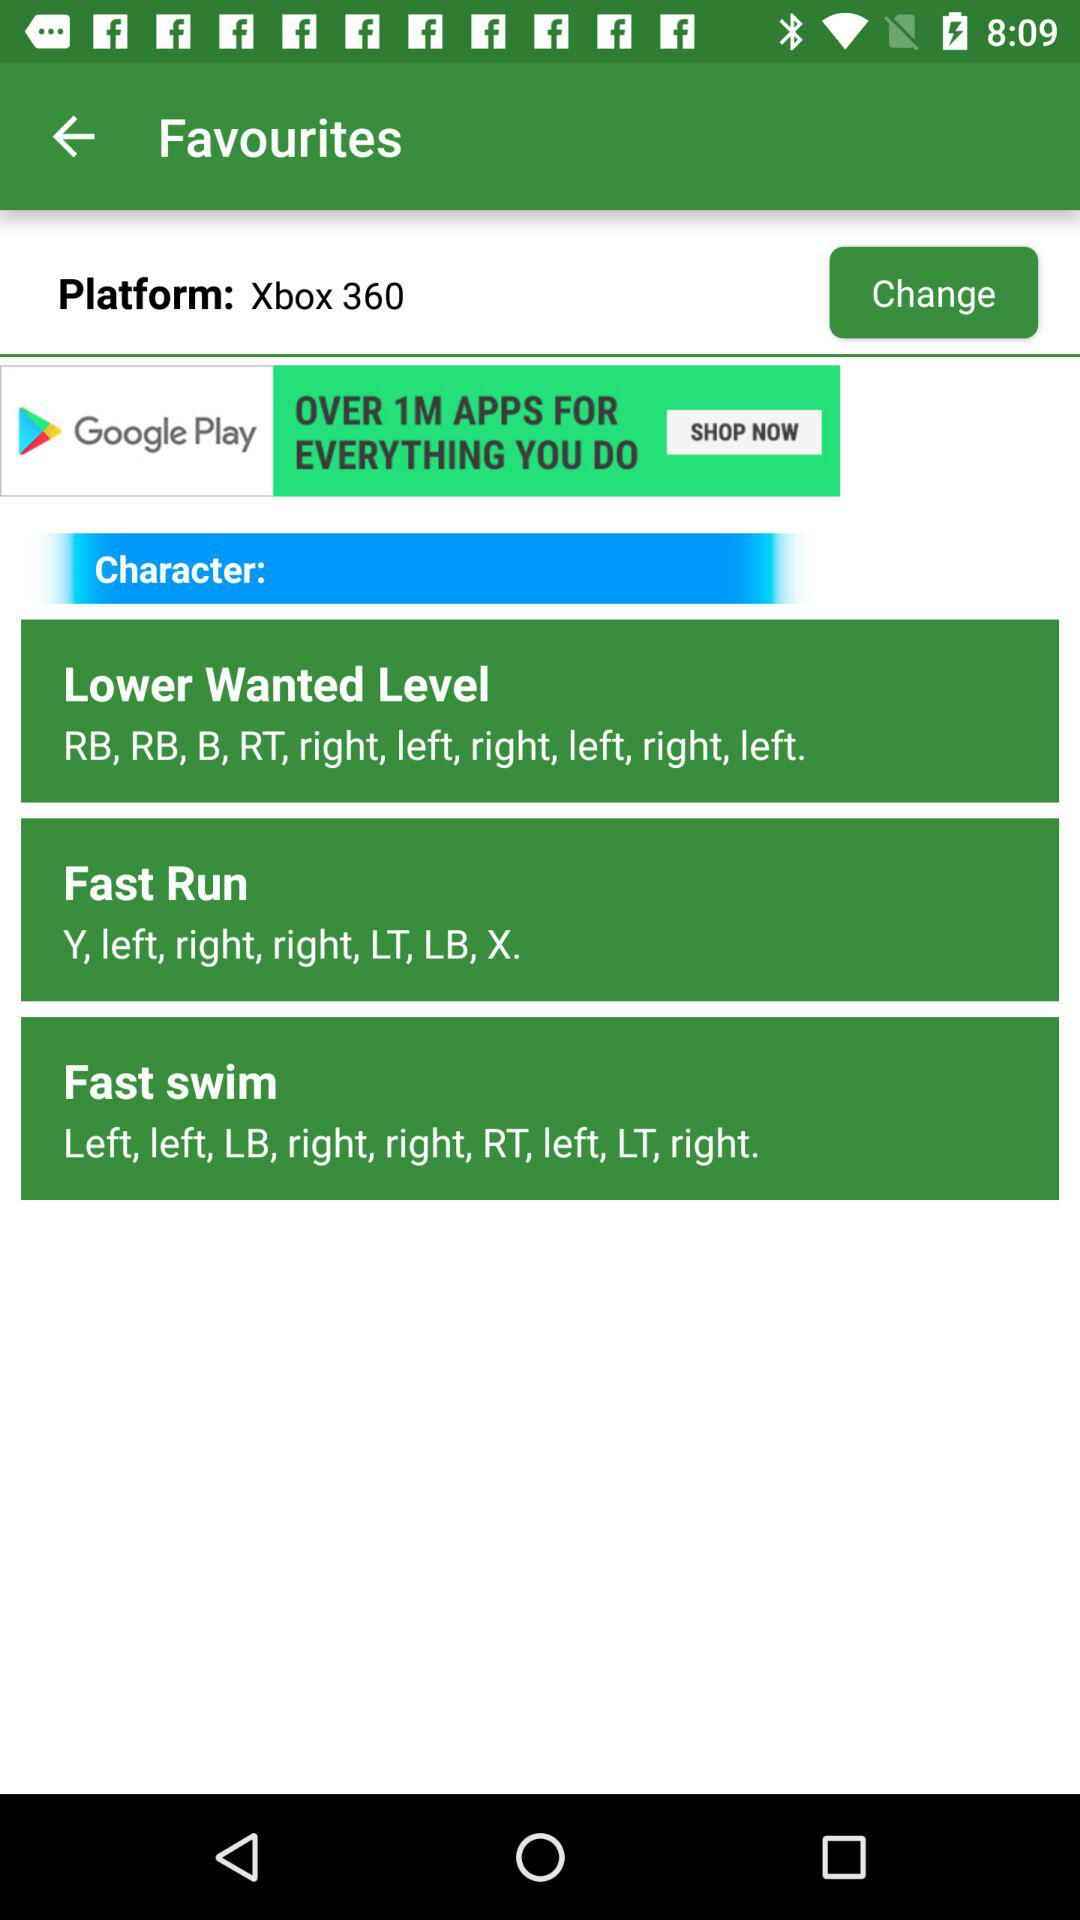What are the buttons in "Fast Run"? The buttons in "Fast Run" are "Y, left, right, right, LT, LB, X". 